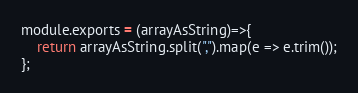<code> <loc_0><loc_0><loc_500><loc_500><_JavaScript_>module.exports = (arrayAsString)=>{
    return arrayAsString.split(",").map(e => e.trim());
};
</code> 